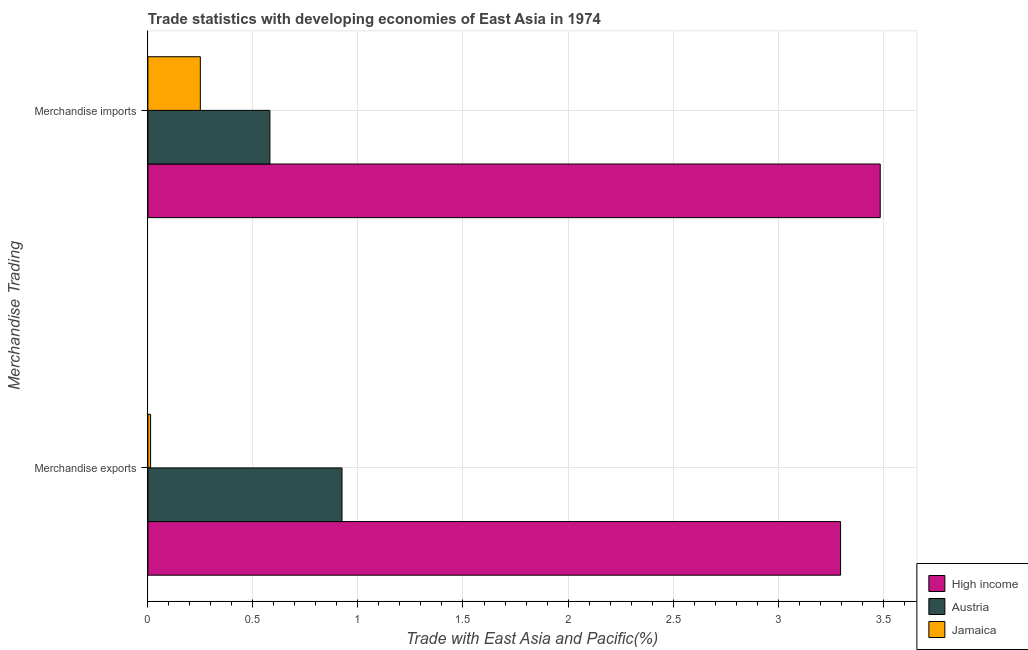How many groups of bars are there?
Your answer should be compact. 2. Are the number of bars on each tick of the Y-axis equal?
Keep it short and to the point. Yes. What is the label of the 2nd group of bars from the top?
Give a very brief answer. Merchandise exports. What is the merchandise exports in High income?
Provide a succinct answer. 3.3. Across all countries, what is the maximum merchandise imports?
Give a very brief answer. 3.49. Across all countries, what is the minimum merchandise imports?
Provide a short and direct response. 0.25. In which country was the merchandise imports maximum?
Offer a terse response. High income. In which country was the merchandise imports minimum?
Offer a terse response. Jamaica. What is the total merchandise imports in the graph?
Keep it short and to the point. 4.32. What is the difference between the merchandise exports in Austria and that in High income?
Your answer should be very brief. -2.37. What is the difference between the merchandise exports in Austria and the merchandise imports in Jamaica?
Give a very brief answer. 0.67. What is the average merchandise exports per country?
Your answer should be compact. 1.41. What is the difference between the merchandise exports and merchandise imports in High income?
Provide a succinct answer. -0.19. What is the ratio of the merchandise imports in High income to that in Jamaica?
Make the answer very short. 13.96. What does the 1st bar from the top in Merchandise exports represents?
Your answer should be very brief. Jamaica. How many countries are there in the graph?
Offer a terse response. 3. What is the difference between two consecutive major ticks on the X-axis?
Your response must be concise. 0.5. How many legend labels are there?
Your answer should be very brief. 3. How are the legend labels stacked?
Make the answer very short. Vertical. What is the title of the graph?
Your response must be concise. Trade statistics with developing economies of East Asia in 1974. What is the label or title of the X-axis?
Make the answer very short. Trade with East Asia and Pacific(%). What is the label or title of the Y-axis?
Provide a short and direct response. Merchandise Trading. What is the Trade with East Asia and Pacific(%) in High income in Merchandise exports?
Give a very brief answer. 3.3. What is the Trade with East Asia and Pacific(%) in Austria in Merchandise exports?
Your response must be concise. 0.92. What is the Trade with East Asia and Pacific(%) in Jamaica in Merchandise exports?
Give a very brief answer. 0.01. What is the Trade with East Asia and Pacific(%) of High income in Merchandise imports?
Provide a short and direct response. 3.49. What is the Trade with East Asia and Pacific(%) of Austria in Merchandise imports?
Make the answer very short. 0.58. What is the Trade with East Asia and Pacific(%) in Jamaica in Merchandise imports?
Ensure brevity in your answer.  0.25. Across all Merchandise Trading, what is the maximum Trade with East Asia and Pacific(%) in High income?
Ensure brevity in your answer.  3.49. Across all Merchandise Trading, what is the maximum Trade with East Asia and Pacific(%) in Austria?
Provide a succinct answer. 0.92. Across all Merchandise Trading, what is the maximum Trade with East Asia and Pacific(%) of Jamaica?
Offer a very short reply. 0.25. Across all Merchandise Trading, what is the minimum Trade with East Asia and Pacific(%) in High income?
Your answer should be compact. 3.3. Across all Merchandise Trading, what is the minimum Trade with East Asia and Pacific(%) in Austria?
Give a very brief answer. 0.58. Across all Merchandise Trading, what is the minimum Trade with East Asia and Pacific(%) in Jamaica?
Offer a terse response. 0.01. What is the total Trade with East Asia and Pacific(%) in High income in the graph?
Offer a very short reply. 6.78. What is the total Trade with East Asia and Pacific(%) in Austria in the graph?
Give a very brief answer. 1.5. What is the total Trade with East Asia and Pacific(%) of Jamaica in the graph?
Make the answer very short. 0.26. What is the difference between the Trade with East Asia and Pacific(%) in High income in Merchandise exports and that in Merchandise imports?
Offer a terse response. -0.19. What is the difference between the Trade with East Asia and Pacific(%) of Austria in Merchandise exports and that in Merchandise imports?
Your answer should be compact. 0.34. What is the difference between the Trade with East Asia and Pacific(%) of Jamaica in Merchandise exports and that in Merchandise imports?
Give a very brief answer. -0.24. What is the difference between the Trade with East Asia and Pacific(%) in High income in Merchandise exports and the Trade with East Asia and Pacific(%) in Austria in Merchandise imports?
Offer a very short reply. 2.72. What is the difference between the Trade with East Asia and Pacific(%) of High income in Merchandise exports and the Trade with East Asia and Pacific(%) of Jamaica in Merchandise imports?
Offer a terse response. 3.05. What is the difference between the Trade with East Asia and Pacific(%) of Austria in Merchandise exports and the Trade with East Asia and Pacific(%) of Jamaica in Merchandise imports?
Provide a short and direct response. 0.67. What is the average Trade with East Asia and Pacific(%) in High income per Merchandise Trading?
Keep it short and to the point. 3.39. What is the average Trade with East Asia and Pacific(%) of Austria per Merchandise Trading?
Give a very brief answer. 0.75. What is the average Trade with East Asia and Pacific(%) of Jamaica per Merchandise Trading?
Your answer should be compact. 0.13. What is the difference between the Trade with East Asia and Pacific(%) of High income and Trade with East Asia and Pacific(%) of Austria in Merchandise exports?
Provide a succinct answer. 2.37. What is the difference between the Trade with East Asia and Pacific(%) in High income and Trade with East Asia and Pacific(%) in Jamaica in Merchandise exports?
Provide a succinct answer. 3.28. What is the difference between the Trade with East Asia and Pacific(%) in Austria and Trade with East Asia and Pacific(%) in Jamaica in Merchandise exports?
Give a very brief answer. 0.91. What is the difference between the Trade with East Asia and Pacific(%) of High income and Trade with East Asia and Pacific(%) of Austria in Merchandise imports?
Keep it short and to the point. 2.91. What is the difference between the Trade with East Asia and Pacific(%) in High income and Trade with East Asia and Pacific(%) in Jamaica in Merchandise imports?
Offer a very short reply. 3.24. What is the difference between the Trade with East Asia and Pacific(%) of Austria and Trade with East Asia and Pacific(%) of Jamaica in Merchandise imports?
Offer a very short reply. 0.33. What is the ratio of the Trade with East Asia and Pacific(%) in High income in Merchandise exports to that in Merchandise imports?
Provide a short and direct response. 0.95. What is the ratio of the Trade with East Asia and Pacific(%) in Austria in Merchandise exports to that in Merchandise imports?
Provide a succinct answer. 1.59. What is the ratio of the Trade with East Asia and Pacific(%) of Jamaica in Merchandise exports to that in Merchandise imports?
Provide a succinct answer. 0.05. What is the difference between the highest and the second highest Trade with East Asia and Pacific(%) of High income?
Your answer should be compact. 0.19. What is the difference between the highest and the second highest Trade with East Asia and Pacific(%) of Austria?
Ensure brevity in your answer.  0.34. What is the difference between the highest and the second highest Trade with East Asia and Pacific(%) in Jamaica?
Provide a short and direct response. 0.24. What is the difference between the highest and the lowest Trade with East Asia and Pacific(%) of High income?
Offer a very short reply. 0.19. What is the difference between the highest and the lowest Trade with East Asia and Pacific(%) of Austria?
Provide a short and direct response. 0.34. What is the difference between the highest and the lowest Trade with East Asia and Pacific(%) of Jamaica?
Offer a terse response. 0.24. 